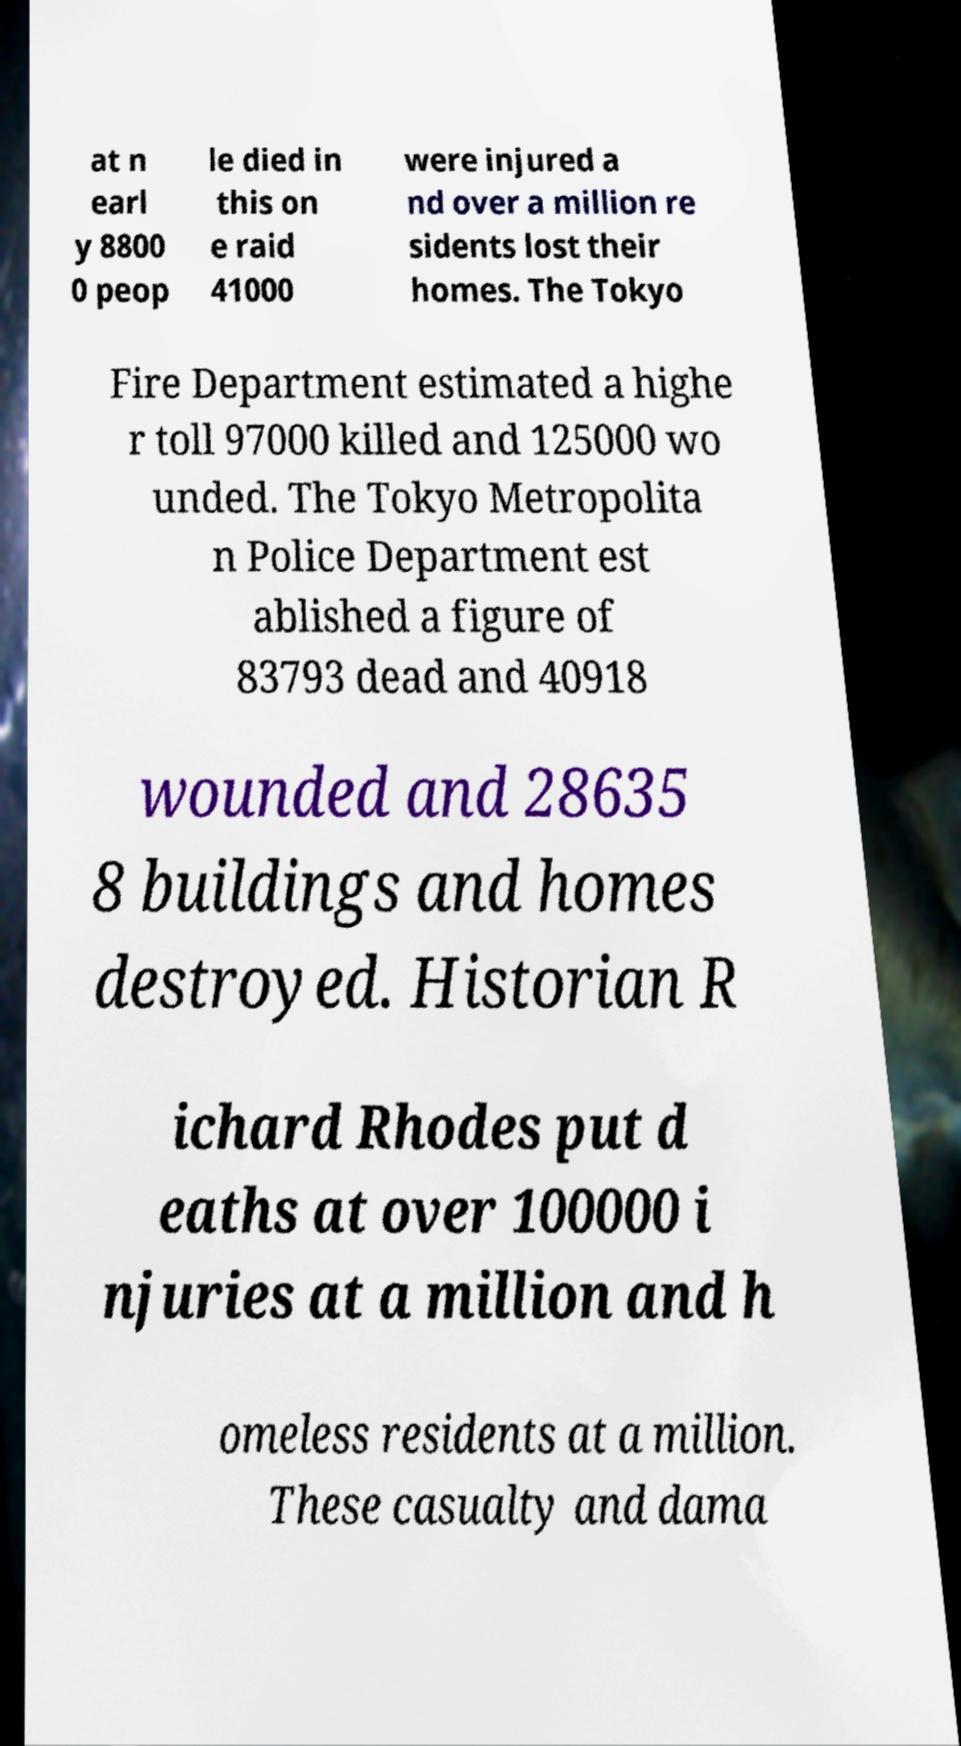Could you extract and type out the text from this image? at n earl y 8800 0 peop le died in this on e raid 41000 were injured a nd over a million re sidents lost their homes. The Tokyo Fire Department estimated a highe r toll 97000 killed and 125000 wo unded. The Tokyo Metropolita n Police Department est ablished a figure of 83793 dead and 40918 wounded and 28635 8 buildings and homes destroyed. Historian R ichard Rhodes put d eaths at over 100000 i njuries at a million and h omeless residents at a million. These casualty and dama 